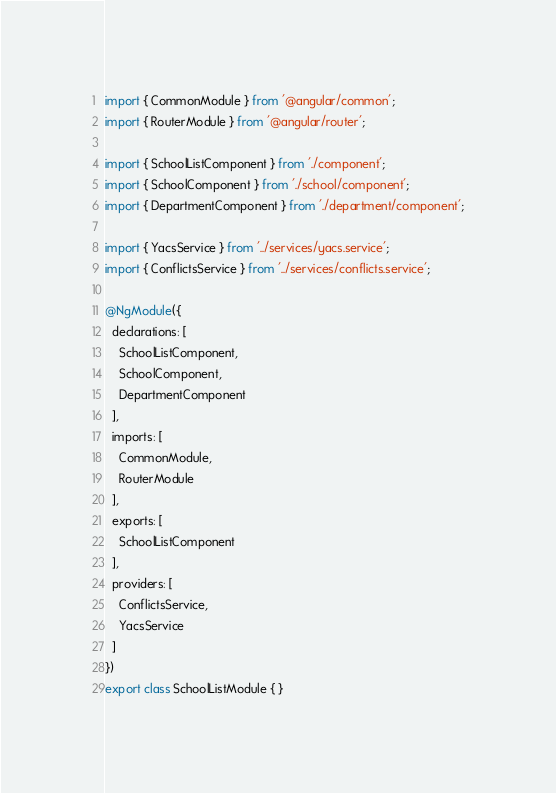<code> <loc_0><loc_0><loc_500><loc_500><_TypeScript_>import { CommonModule } from '@angular/common';
import { RouterModule } from '@angular/router';

import { SchoolListComponent } from './component';
import { SchoolComponent } from './school/component';
import { DepartmentComponent } from './department/component';

import { YacsService } from '../services/yacs.service';
import { ConflictsService } from '../services/conflicts.service';

@NgModule({
  declarations: [
    SchoolListComponent,
    SchoolComponent,
    DepartmentComponent
  ],
  imports: [
    CommonModule,
    RouterModule
  ],
  exports: [
    SchoolListComponent
  ],
  providers: [
    ConflictsService,
    YacsService
  ]
})
export class SchoolListModule { }
</code> 